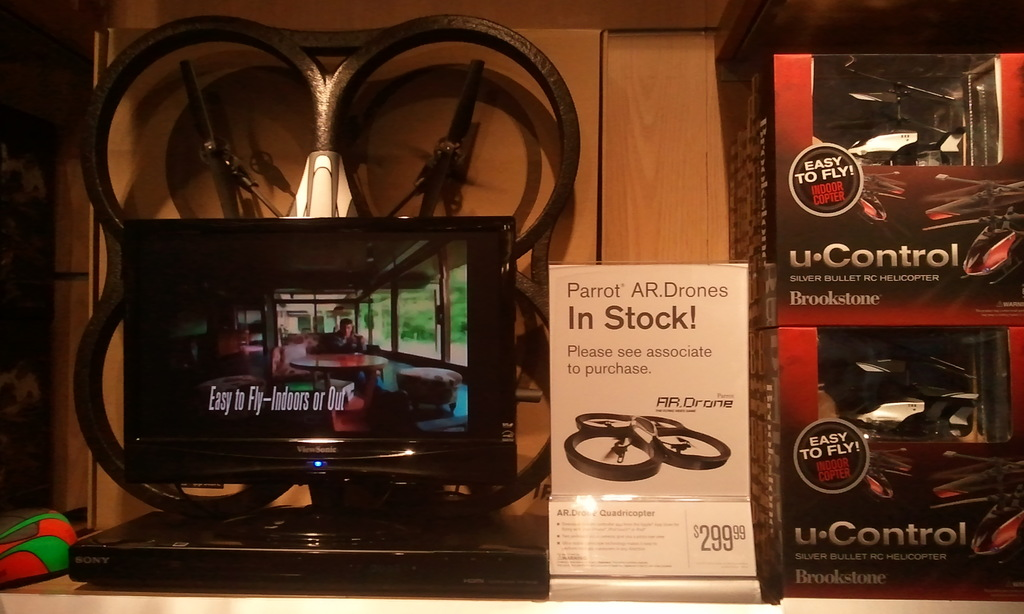Provide a one-sentence caption for the provided image. A retail store shelf displays a variety of drones, prominently featuring Parrot AR drones next to an advertising placard, alongside a portable DVD player showing a video, emphasizing the drones' ease of use indoors or outdoors. 